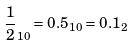<formula> <loc_0><loc_0><loc_500><loc_500>\frac { 1 } { 2 } _ { 1 0 } = 0 . 5 _ { 1 0 } = 0 . 1 _ { 2 }</formula> 